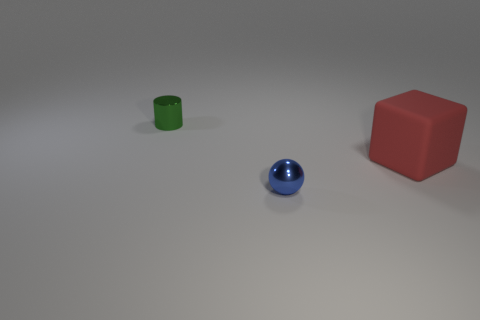What number of things have the same material as the big red cube?
Provide a short and direct response. 0. There is a small thing that is in front of the big red rubber block; what number of big things are on the left side of it?
Your response must be concise. 0. What shape is the object that is behind the tiny blue shiny ball and in front of the tiny cylinder?
Your response must be concise. Cube. The blue object that is the same size as the green metal cylinder is what shape?
Provide a succinct answer. Sphere. What is the material of the cube?
Make the answer very short. Rubber. There is a thing on the right side of the small metallic thing in front of the red block on the right side of the small shiny cylinder; how big is it?
Your answer should be compact. Large. How many matte objects are either red blocks or blue blocks?
Give a very brief answer. 1. What size is the red matte object?
Offer a very short reply. Large. How many objects are either gray rubber objects or objects behind the tiny metallic ball?
Give a very brief answer. 2. There is a sphere; is it the same size as the metallic object behind the large red object?
Offer a terse response. Yes. 